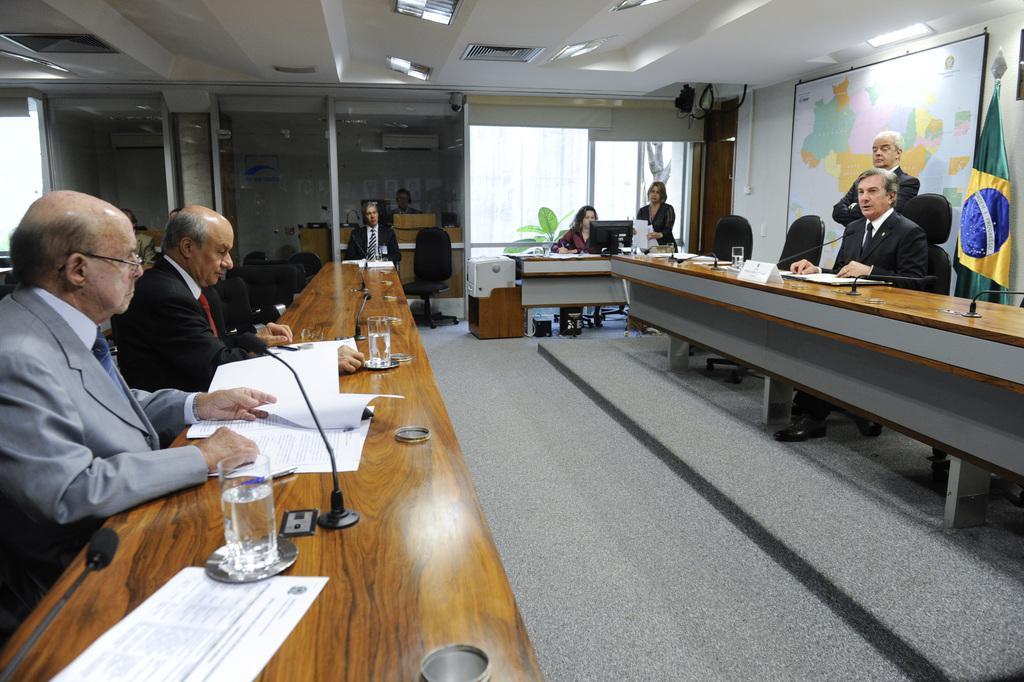Please provide a concise description of this image. in this image i can see number of people sitting on chairs in front of the table, On the table i can see few microphones, few glasses and few papers. In the background i can see a chair, a plant, a monitor, few people standing, a map, a flag, and few other rooms. 